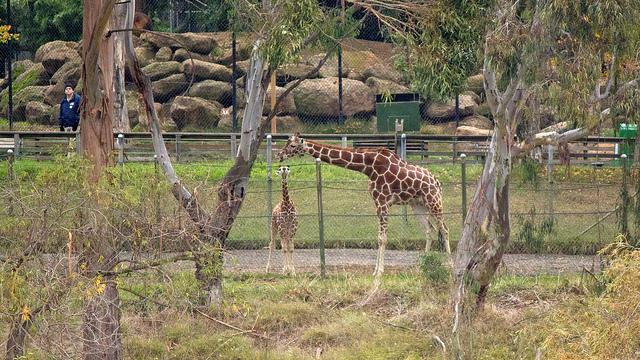How many animals are depicted?
Short answer required. 2. How many people are watching the animal?
Keep it brief. 1. Is this the wild?
Short answer required. No. Are the giraffes looking for food?
Write a very short answer. No. 